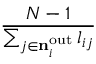Convert formula to latex. <formula><loc_0><loc_0><loc_500><loc_500>\frac { N - 1 } { \sum _ { j \in { { n } _ { i } ^ { o u t } } } l _ { i j } }</formula> 